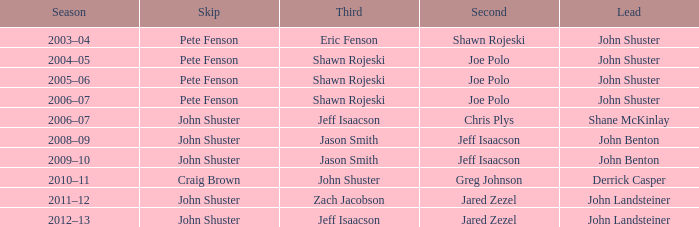Who was the primary team member with john shuster as skip, chris plys in second, and jeff isaacson in third? Shane McKinlay. 